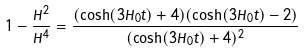<formula> <loc_0><loc_0><loc_500><loc_500>1 - \frac { \dot { H } ^ { 2 } } { H ^ { 4 } } = \frac { ( \cosh ( 3 H _ { 0 } t ) + 4 ) ( \cosh ( 3 H _ { 0 } t ) - 2 ) } { ( \cosh ( 3 H _ { 0 } t ) + 4 ) ^ { 2 } }</formula> 